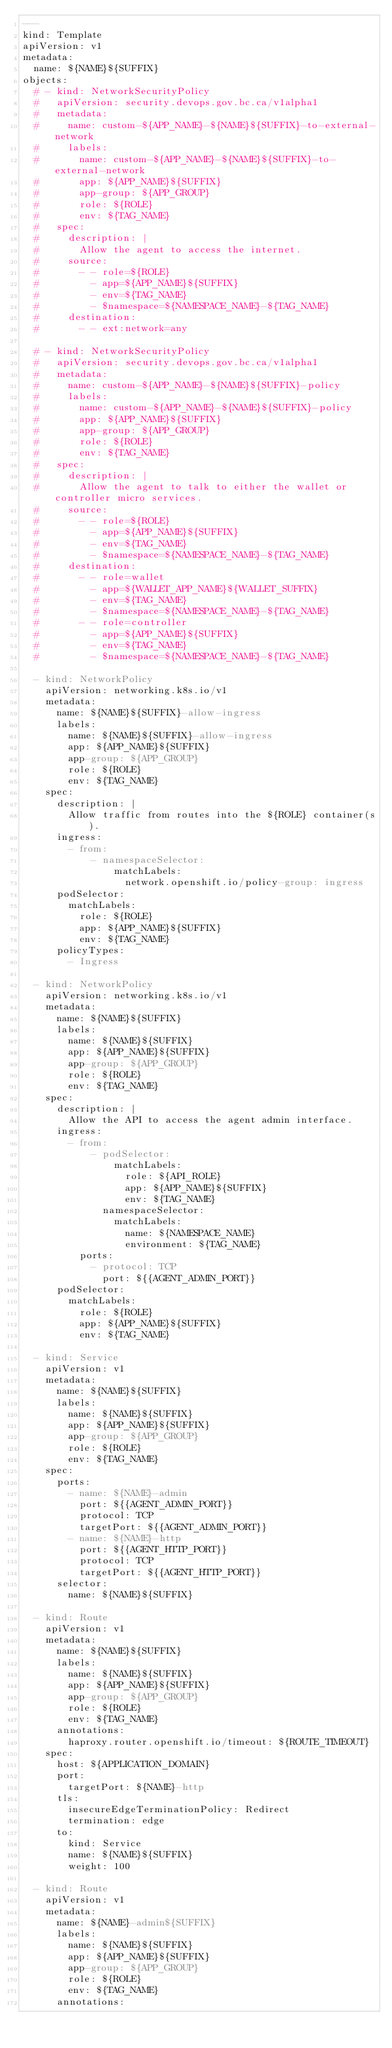<code> <loc_0><loc_0><loc_500><loc_500><_YAML_>---
kind: Template
apiVersion: v1
metadata:
  name: ${NAME}${SUFFIX}
objects:
  # - kind: NetworkSecurityPolicy
  #   apiVersion: security.devops.gov.bc.ca/v1alpha1
  #   metadata:
  #     name: custom-${APP_NAME}-${NAME}${SUFFIX}-to-external-network
  #     labels:
  #       name: custom-${APP_NAME}-${NAME}${SUFFIX}-to-external-network
  #       app: ${APP_NAME}${SUFFIX}
  #       app-group: ${APP_GROUP}
  #       role: ${ROLE}
  #       env: ${TAG_NAME}
  #   spec:
  #     description: |
  #       Allow the agent to access the internet.
  #     source:
  #       - - role=${ROLE}
  #         - app=${APP_NAME}${SUFFIX}
  #         - env=${TAG_NAME}
  #         - $namespace=${NAMESPACE_NAME}-${TAG_NAME}
  #     destination:
  #       - - ext:network=any

  # - kind: NetworkSecurityPolicy
  #   apiVersion: security.devops.gov.bc.ca/v1alpha1
  #   metadata:
  #     name: custom-${APP_NAME}-${NAME}${SUFFIX}-policy
  #     labels:
  #       name: custom-${APP_NAME}-${NAME}${SUFFIX}-policy
  #       app: ${APP_NAME}${SUFFIX}
  #       app-group: ${APP_GROUP}
  #       role: ${ROLE}
  #       env: ${TAG_NAME}
  #   spec:
  #     description: |
  #       Allow the agent to talk to either the wallet or controller micro services.
  #     source:
  #       - - role=${ROLE}
  #         - app=${APP_NAME}${SUFFIX}
  #         - env=${TAG_NAME}
  #         - $namespace=${NAMESPACE_NAME}-${TAG_NAME}
  #     destination:
  #       - - role=wallet
  #         - app=${WALLET_APP_NAME}${WALLET_SUFFIX}
  #         - env=${TAG_NAME}
  #         - $namespace=${NAMESPACE_NAME}-${TAG_NAME}
  #       - - role=controller
  #         - app=${APP_NAME}${SUFFIX}
  #         - env=${TAG_NAME}
  #         - $namespace=${NAMESPACE_NAME}-${TAG_NAME}

  - kind: NetworkPolicy
    apiVersion: networking.k8s.io/v1
    metadata:
      name: ${NAME}${SUFFIX}-allow-ingress
      labels:
        name: ${NAME}${SUFFIX}-allow-ingress
        app: ${APP_NAME}${SUFFIX}
        app-group: ${APP_GROUP}
        role: ${ROLE}
        env: ${TAG_NAME}
    spec:
      description: |
        Allow traffic from routes into the ${ROLE} container(s).
      ingress:
        - from:
            - namespaceSelector:
                matchLabels:
                  network.openshift.io/policy-group: ingress
      podSelector:
        matchLabels:
          role: ${ROLE}
          app: ${APP_NAME}${SUFFIX}
          env: ${TAG_NAME}
      policyTypes:
        - Ingress

  - kind: NetworkPolicy
    apiVersion: networking.k8s.io/v1
    metadata:
      name: ${NAME}${SUFFIX}
      labels:
        name: ${NAME}${SUFFIX}
        app: ${APP_NAME}${SUFFIX}
        app-group: ${APP_GROUP}
        role: ${ROLE}
        env: ${TAG_NAME}
    spec:
      description: |
        Allow the API to access the agent admin interface.
      ingress:
        - from:
            - podSelector:
                matchLabels:
                  role: ${API_ROLE}
                  app: ${APP_NAME}${SUFFIX}
                  env: ${TAG_NAME}
              namespaceSelector:
                matchLabels:
                  name: ${NAMESPACE_NAME}
                  environment: ${TAG_NAME}
          ports:
            - protocol: TCP
              port: ${{AGENT_ADMIN_PORT}}
      podSelector:
        matchLabels:
          role: ${ROLE}
          app: ${APP_NAME}${SUFFIX}
          env: ${TAG_NAME}

  - kind: Service
    apiVersion: v1
    metadata:
      name: ${NAME}${SUFFIX}
      labels:
        name: ${NAME}${SUFFIX}
        app: ${APP_NAME}${SUFFIX}
        app-group: ${APP_GROUP}
        role: ${ROLE}
        env: ${TAG_NAME}
    spec:
      ports:
        - name: ${NAME}-admin
          port: ${{AGENT_ADMIN_PORT}}
          protocol: TCP
          targetPort: ${{AGENT_ADMIN_PORT}}
        - name: ${NAME}-http
          port: ${{AGENT_HTTP_PORT}}
          protocol: TCP
          targetPort: ${{AGENT_HTTP_PORT}}
      selector:
        name: ${NAME}${SUFFIX}

  - kind: Route
    apiVersion: v1
    metadata:
      name: ${NAME}${SUFFIX}
      labels:
        name: ${NAME}${SUFFIX}
        app: ${APP_NAME}${SUFFIX}
        app-group: ${APP_GROUP}
        role: ${ROLE}
        env: ${TAG_NAME}
      annotations:
        haproxy.router.openshift.io/timeout: ${ROUTE_TIMEOUT}
    spec:
      host: ${APPLICATION_DOMAIN}
      port:
        targetPort: ${NAME}-http
      tls:
        insecureEdgeTerminationPolicy: Redirect
        termination: edge
      to:
        kind: Service
        name: ${NAME}${SUFFIX}
        weight: 100

  - kind: Route
    apiVersion: v1
    metadata:
      name: ${NAME}-admin${SUFFIX}
      labels:
        name: ${NAME}${SUFFIX}
        app: ${APP_NAME}${SUFFIX}
        app-group: ${APP_GROUP}
        role: ${ROLE}
        env: ${TAG_NAME}
      annotations:</code> 